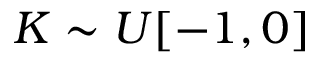Convert formula to latex. <formula><loc_0><loc_0><loc_500><loc_500>K \sim U [ - 1 , 0 ]</formula> 